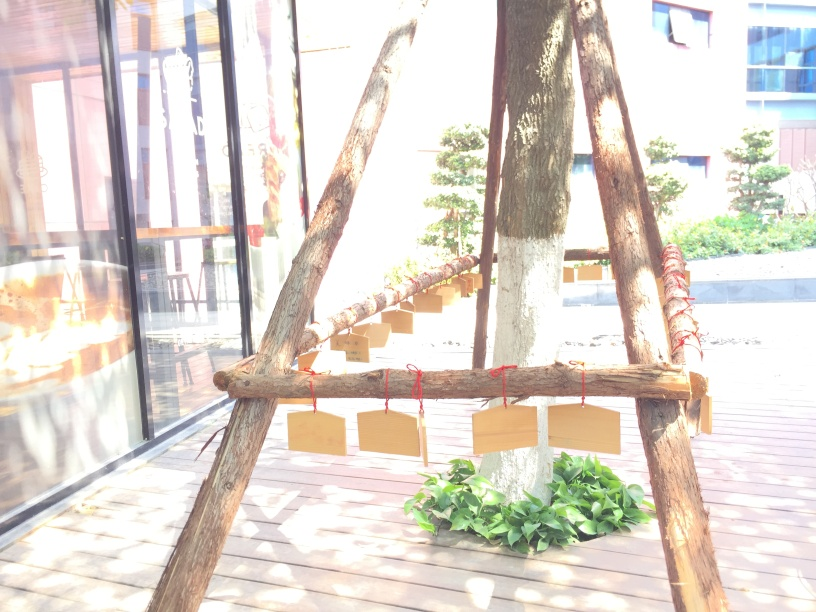Is there something unique about the construction or design of what I'm seeing? The structure in the image appears to be a rustic wooden tripod, possibly part of a swing or signpost. Its naturalistic and unprocessed look suggests a design that integrates with the outdoors or a 'back to nature' aesthetic. 